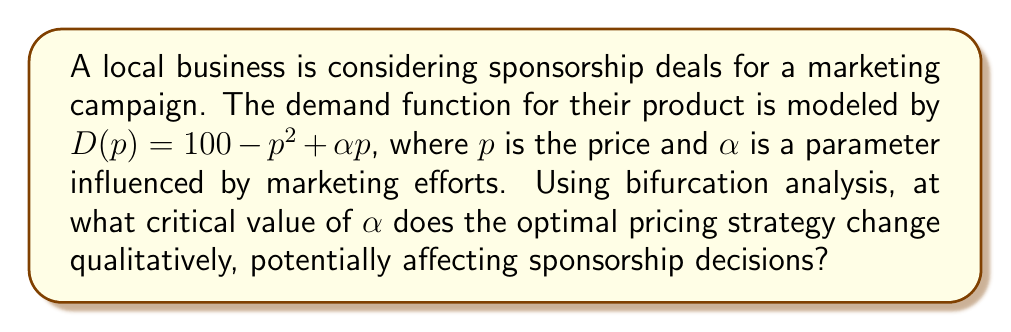Give your solution to this math problem. To solve this problem, we'll follow these steps:

1) The revenue function is given by $R(p) = p \cdot D(p) = p(100 - p^2 + \alpha p)$.

2) To find the optimal price, we differentiate $R(p)$ with respect to $p$ and set it to zero:

   $$\frac{dR}{dp} = 100 - 3p^2 + 2\alpha p = 0$$

3) This equation represents a cubic function in $p$. The number of real roots of this equation determines the number of critical points of the revenue function.

4) For a cubic equation $ax^3 + bx^2 + cx + d = 0$, the discriminant is given by:
   
   $$\Delta = 18abcd - 4b^3d + b^2c^2 - 4ac^3 - 27a^2d^2$$

5) In our case, $a=-3$, $b=2\alpha$, $c=0$, and $d=100$. Substituting these values:

   $$\Delta = 18(-3)(2\alpha)(0)(100) - 4(2\alpha)^3(100) + (2\alpha)^2(0)^2 - 4(-3)(0)^3 - 27(-3)^2(100)^2$$
   
   $$\Delta = -3200\alpha^3 - 2430000$$

6) The bifurcation occurs when the discriminant changes sign, i.e., when $\Delta = 0$:

   $$-3200\alpha^3 - 2430000 = 0$$

7) Solving this equation:

   $$\alpha^3 = -759.375$$
   $$\alpha = -9.1$$

This is the critical value of $\alpha$ where the behavior of the system changes qualitatively.
Answer: $\alpha = -9.1$ 